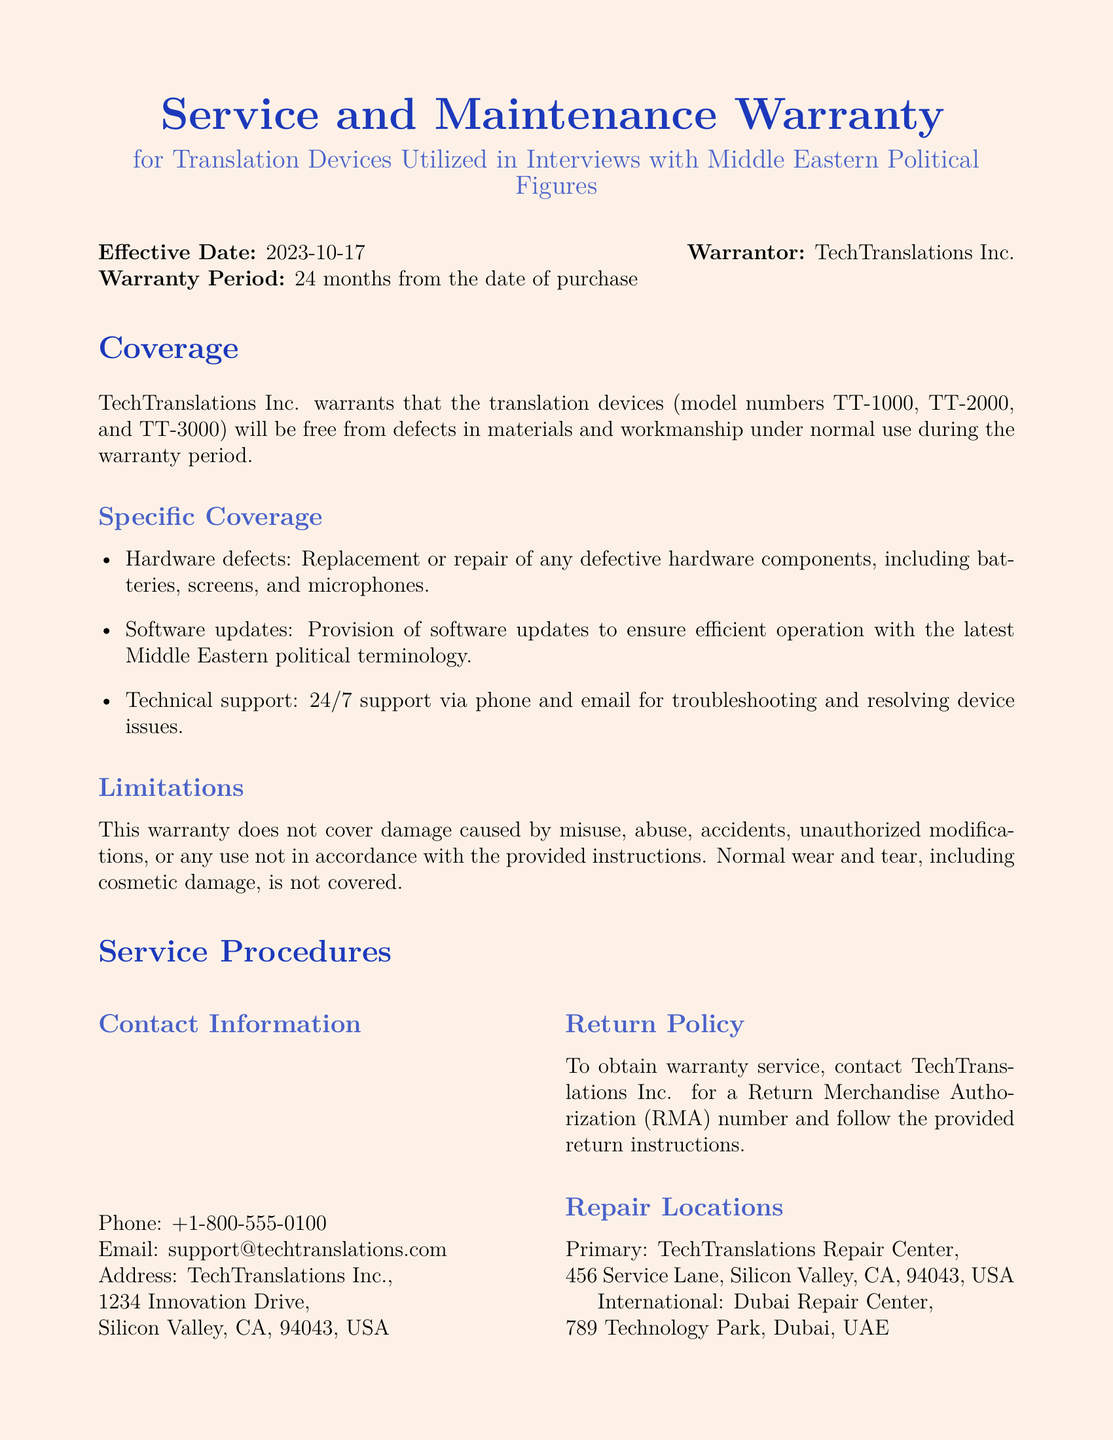What is the effective date of the warranty? The effective date is stated clearly at the beginning of the document.
Answer: 2023-10-17 How long is the warranty period? The warranty period is mentioned in the introduction which specifies its duration.
Answer: 24 months Which model numbers are covered under this warranty? The model numbers are explicitly listed in the coverage section of the document.
Answer: TT-1000, TT-2000, TT-3000 What type of support is offered? The specific kind of support provided is stated under the specific coverage section.
Answer: 24/7 support What is excluded from the warranty coverage? Exclusions are listed at the end of the coverage section, outlining specific situations not covered.
Answer: Misuse, abuse, accidents Where is the primary repair location? The primary repair location is mentioned in the service procedures section of the document.
Answer: TechTranslations Repair Center What must one obtain to receive warranty service? This requirement is specified in the service procedures section detailing how to initiate a warranty claim.
Answer: Return Merchandise Authorization (RMA) number Who is the signatory at the end of the document? The name and position of the signatory are noted at the bottom of the document.
Answer: John Doe, CEO What does TechTranslations Inc. disclaim in the warranty? The disclaimers are mentioned in the exclusions and disclaimer section specifying limitations.
Answer: No other express or implied warranties 